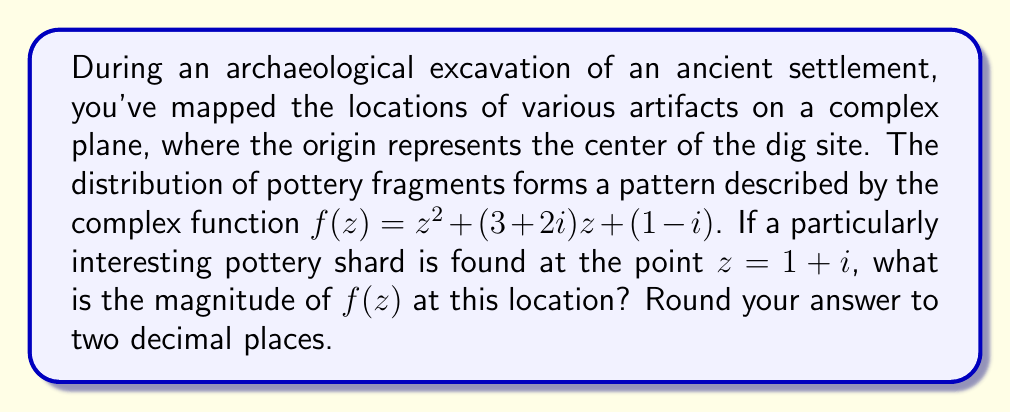Solve this math problem. Let's approach this step-by-step:

1) We're given the function $f(z) = z^2 + (3+2i)z + (1-i)$

2) We need to evaluate this function at $z = 1+i$

3) Let's substitute $z = 1+i$ into the function:

   $f(1+i) = (1+i)^2 + (3+2i)(1+i) + (1-i)$

4) Let's evaluate each term:
   
   a) $(1+i)^2 = 1^2 + 2i - 1 = 2i$
   
   b) $(3+2i)(1+i) = 3+3i+2i-2 = 1+5i$
   
   c) $(1-i)$ remains as is

5) Now we can add these terms:

   $f(1+i) = 2i + (1+5i) + (1-i) = 2+6i$

6) To find the magnitude of this complex number, we use the formula $|a+bi| = \sqrt{a^2 + b^2}$

7) In this case, $a=2$ and $b=6$:

   $|2+6i| = \sqrt{2^2 + 6^2} = \sqrt{4 + 36} = \sqrt{40} = 2\sqrt{10} \approx 6.32$

8) Rounding to two decimal places gives us 6.32.
Answer: 6.32 